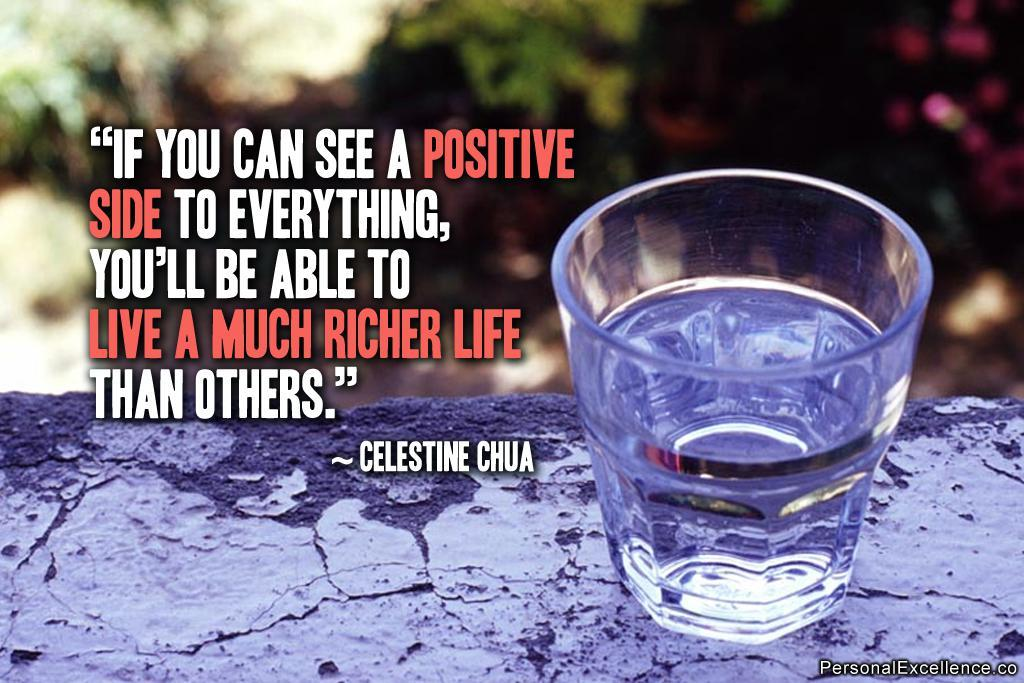<image>
Relay a brief, clear account of the picture shown. A positive quote by Celestine Chua is written next to a glass of water. 